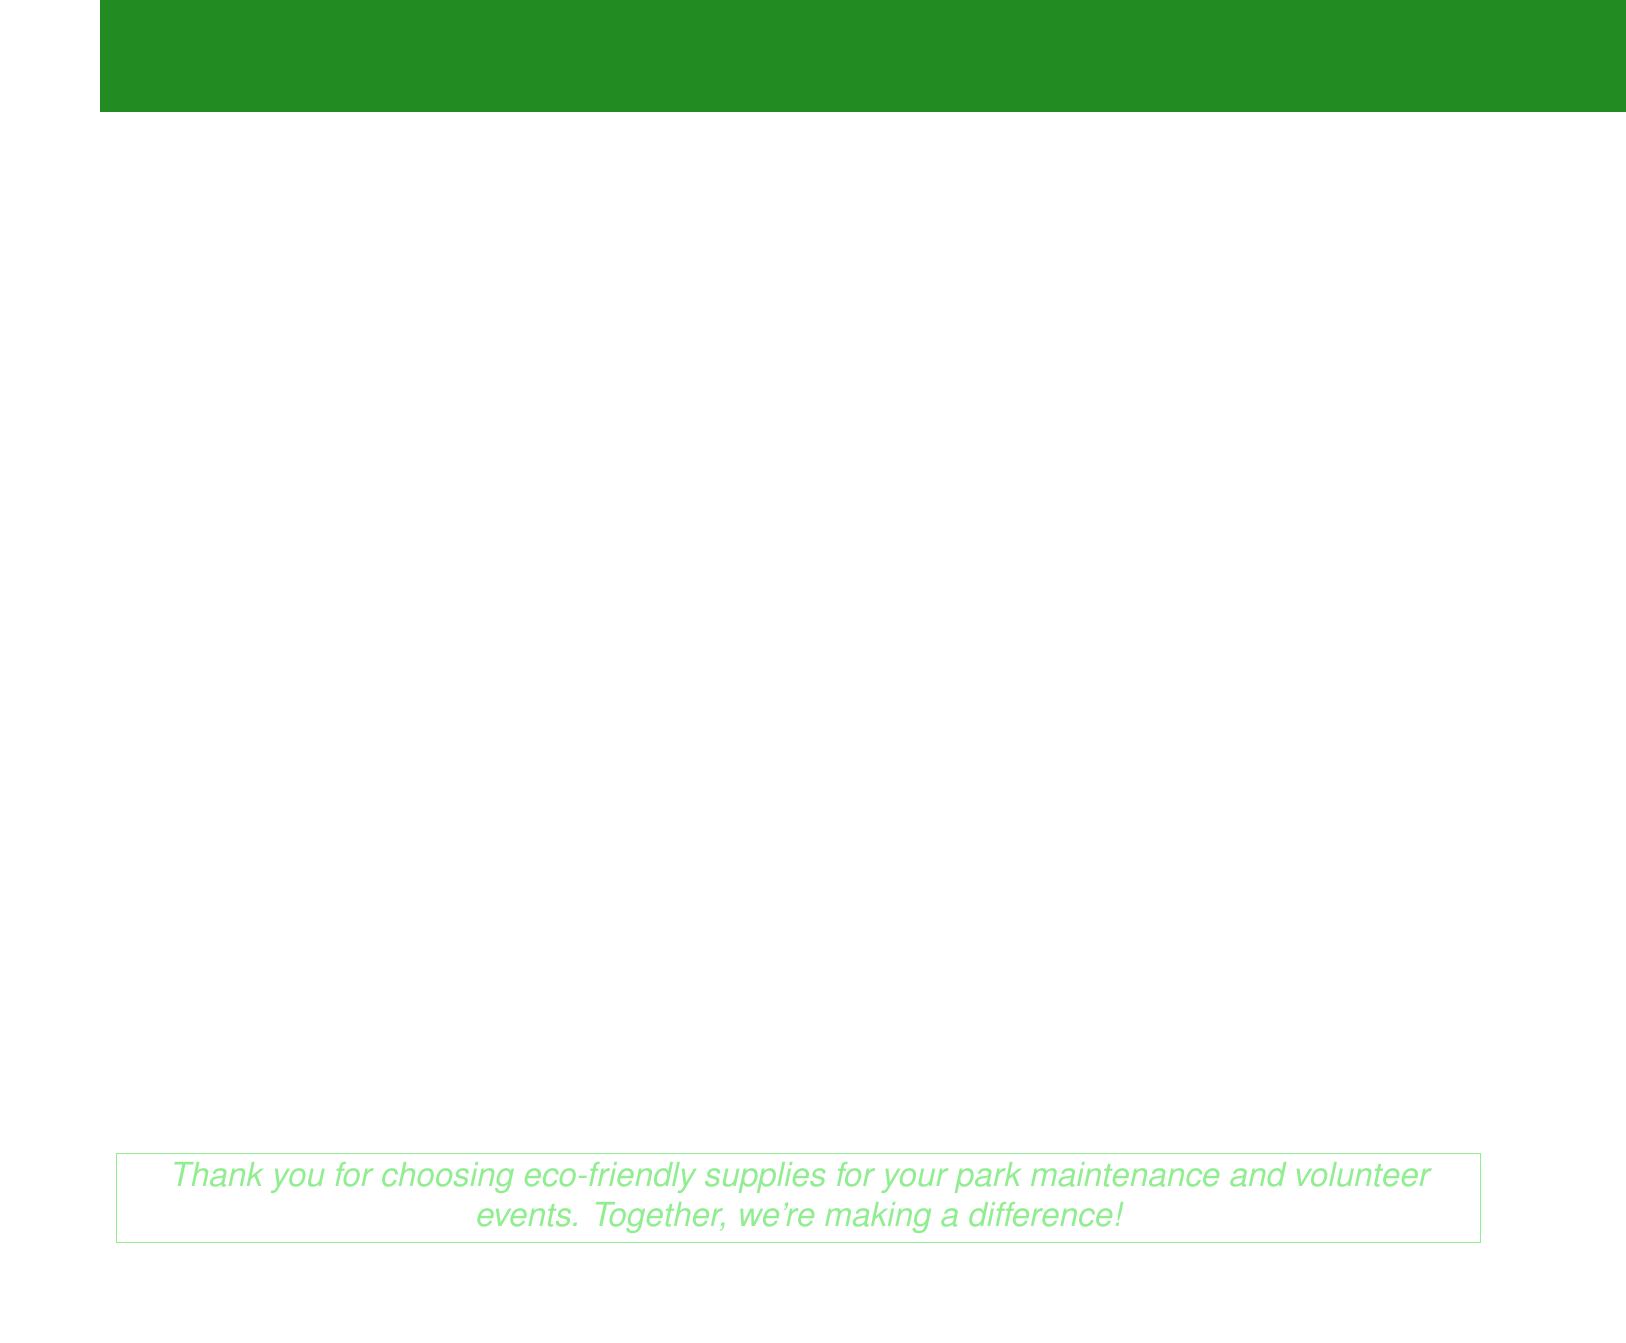What is the invoice number? The invoice number is specifically stated in the document to identify the bill, which is INV-2023-0542.
Answer: INV-2023-0542 What is the date of the invoice? The date reflects when the invoice was issued, which is May 15, 2023.
Answer: May 15, 2023 What is the subtotal for the items listed? The subtotal is the sum of all items before tax, which is $3,498.60.
Answer: $3,498.60 How many EcoGlove pairs were ordered? The quantity of EcoGlove pairs is mentioned in the document, which is 25.
Answer: 25 What is the total amount due? The total amount due includes the subtotal and tax, which is $3,787.23.
Answer: $3,787.23 What is the tax rate applied to the invoice? The tax rate is outlined in the document as 8.25%.
Answer: 8.25% Who is the contact person for the bill? The document specifies Alex Thompson as the contact person from Redwood National Park.
Answer: Alex Thompson How many GreenPick litter pickers were ordered? The number of GreenPick litter pickers can be found in the document, which is 50.
Answer: 50 What company issued the invoice? The company issuing the invoice is EcoGuard Park Supplies, as stated at the top of the document.
Answer: EcoGuard Park Supplies 